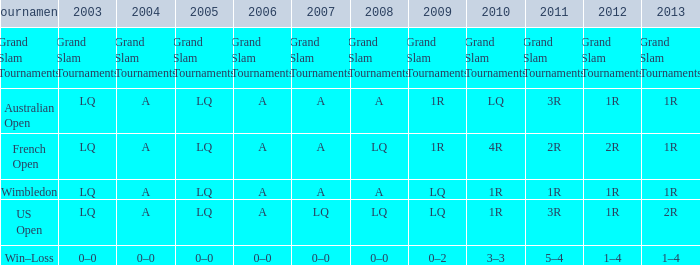Write the full table. {'header': ['Tournament', '2003', '2004', '2005', '2006', '2007', '2008', '2009', '2010', '2011', '2012', '2013'], 'rows': [['Grand Slam Tournaments', 'Grand Slam Tournaments', 'Grand Slam Tournaments', 'Grand Slam Tournaments', 'Grand Slam Tournaments', 'Grand Slam Tournaments', 'Grand Slam Tournaments', 'Grand Slam Tournaments', 'Grand Slam Tournaments', 'Grand Slam Tournaments', 'Grand Slam Tournaments', 'Grand Slam Tournaments'], ['Australian Open', 'LQ', 'A', 'LQ', 'A', 'A', 'A', '1R', 'LQ', '3R', '1R', '1R'], ['French Open', 'LQ', 'A', 'LQ', 'A', 'A', 'LQ', '1R', '4R', '2R', '2R', '1R'], ['Wimbledon', 'LQ', 'A', 'LQ', 'A', 'A', 'A', 'LQ', '1R', '1R', '1R', '1R'], ['US Open', 'LQ', 'A', 'LQ', 'A', 'LQ', 'LQ', 'LQ', '1R', '3R', '1R', '2R'], ['Win–Loss', '0–0', '0–0', '0–0', '0–0', '0–0', '0–0', '0–2', '3–3', '5–4', '1–4', '1–4']]} Which tournament has a 2013 of 1r, and a 2012 of 1r? Australian Open, Wimbledon. 